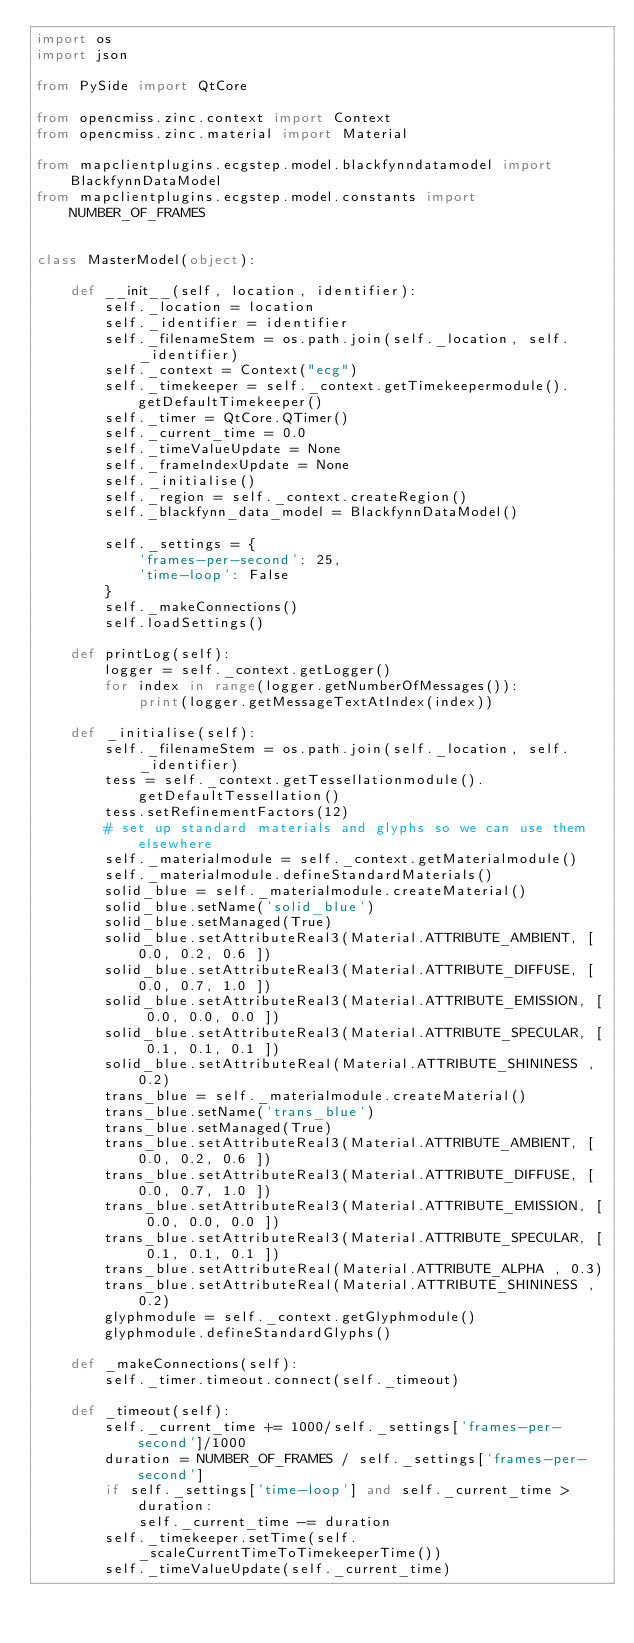Convert code to text. <code><loc_0><loc_0><loc_500><loc_500><_Python_>import os
import json

from PySide import QtCore

from opencmiss.zinc.context import Context
from opencmiss.zinc.material import Material

from mapclientplugins.ecgstep.model.blackfynndatamodel import BlackfynnDataModel
from mapclientplugins.ecgstep.model.constants import NUMBER_OF_FRAMES


class MasterModel(object):

    def __init__(self, location, identifier):
        self._location = location
        self._identifier = identifier
        self._filenameStem = os.path.join(self._location, self._identifier)
        self._context = Context("ecg")
        self._timekeeper = self._context.getTimekeepermodule().getDefaultTimekeeper()
        self._timer = QtCore.QTimer()
        self._current_time = 0.0
        self._timeValueUpdate = None
        self._frameIndexUpdate = None
        self._initialise()
        self._region = self._context.createRegion()
        self._blackfynn_data_model = BlackfynnDataModel()

        self._settings = {
            'frames-per-second': 25,
            'time-loop': False
        }
        self._makeConnections()
        self.loadSettings()

    def printLog(self):
        logger = self._context.getLogger()
        for index in range(logger.getNumberOfMessages()):
            print(logger.getMessageTextAtIndex(index))

    def _initialise(self):
        self._filenameStem = os.path.join(self._location, self._identifier)
        tess = self._context.getTessellationmodule().getDefaultTessellation()
        tess.setRefinementFactors(12)
        # set up standard materials and glyphs so we can use them elsewhere
        self._materialmodule = self._context.getMaterialmodule()
        self._materialmodule.defineStandardMaterials()
        solid_blue = self._materialmodule.createMaterial()
        solid_blue.setName('solid_blue')
        solid_blue.setManaged(True)
        solid_blue.setAttributeReal3(Material.ATTRIBUTE_AMBIENT, [ 0.0, 0.2, 0.6 ])
        solid_blue.setAttributeReal3(Material.ATTRIBUTE_DIFFUSE, [ 0.0, 0.7, 1.0 ])
        solid_blue.setAttributeReal3(Material.ATTRIBUTE_EMISSION, [ 0.0, 0.0, 0.0 ])
        solid_blue.setAttributeReal3(Material.ATTRIBUTE_SPECULAR, [ 0.1, 0.1, 0.1 ])
        solid_blue.setAttributeReal(Material.ATTRIBUTE_SHININESS , 0.2)
        trans_blue = self._materialmodule.createMaterial()
        trans_blue.setName('trans_blue')
        trans_blue.setManaged(True)
        trans_blue.setAttributeReal3(Material.ATTRIBUTE_AMBIENT, [ 0.0, 0.2, 0.6 ])
        trans_blue.setAttributeReal3(Material.ATTRIBUTE_DIFFUSE, [ 0.0, 0.7, 1.0 ])
        trans_blue.setAttributeReal3(Material.ATTRIBUTE_EMISSION, [ 0.0, 0.0, 0.0 ])
        trans_blue.setAttributeReal3(Material.ATTRIBUTE_SPECULAR, [ 0.1, 0.1, 0.1 ])
        trans_blue.setAttributeReal(Material.ATTRIBUTE_ALPHA , 0.3)
        trans_blue.setAttributeReal(Material.ATTRIBUTE_SHININESS , 0.2)
        glyphmodule = self._context.getGlyphmodule()
        glyphmodule.defineStandardGlyphs()

    def _makeConnections(self):
        self._timer.timeout.connect(self._timeout)

    def _timeout(self):
        self._current_time += 1000/self._settings['frames-per-second']/1000
        duration = NUMBER_OF_FRAMES / self._settings['frames-per-second']
        if self._settings['time-loop'] and self._current_time > duration:
            self._current_time -= duration
        self._timekeeper.setTime(self._scaleCurrentTimeToTimekeeperTime())
        self._timeValueUpdate(self._current_time)
</code> 